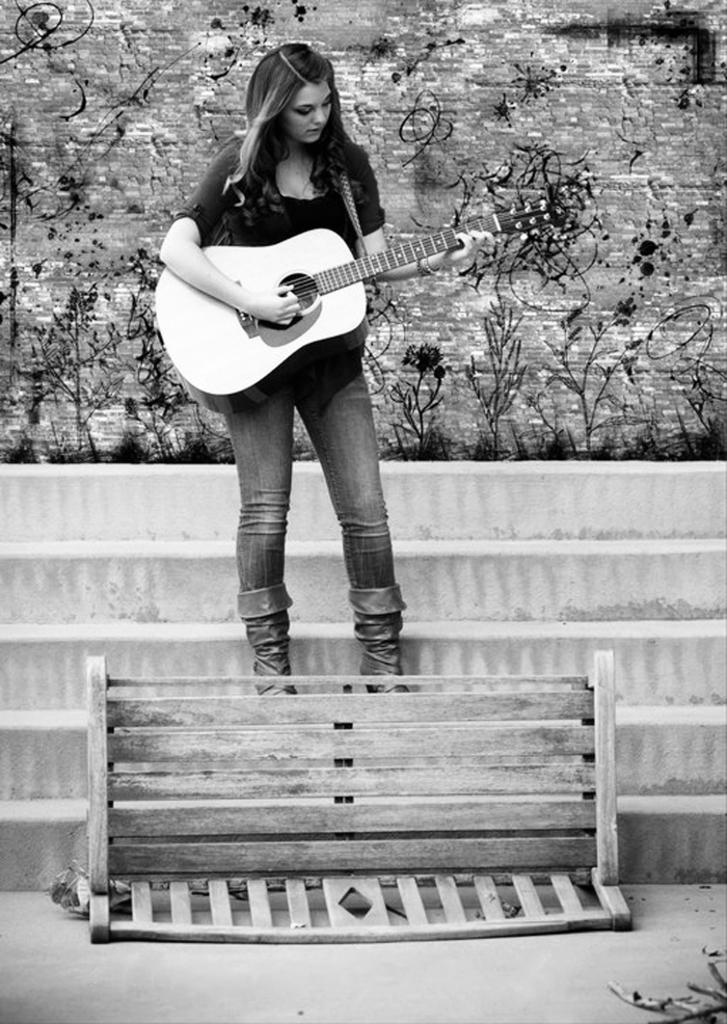Who is present in the image? There is a woman in the image. What is the woman doing in the image? The woman is standing in the image. What object is the woman holding in her hand? The woman is holding a guitar in her hand. What architectural features can be seen in the image? There are stairs and a bench in the image. What type of vegetation is present in the image? There is a plant in the image. What is the weight of the joke being told by the woman in the image? There is no joke being told in the image, so it is not possible to determine the weight of a joke. 